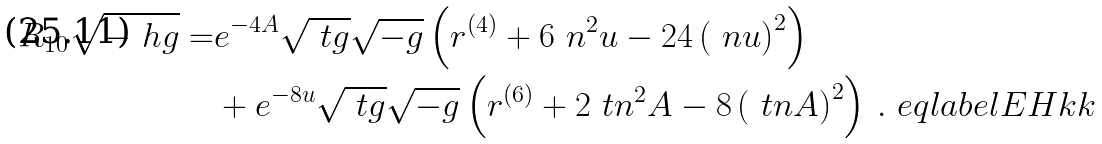<formula> <loc_0><loc_0><loc_500><loc_500>R _ { 1 0 } \sqrt { - \ h g } = & e ^ { - 4 A } \sqrt { \ t g } \sqrt { - g } \left ( r ^ { ( 4 ) } + 6 \ n ^ { 2 } u - 2 4 \left ( \ n u \right ) ^ { 2 } \right ) \\ & + e ^ { - 8 u } \sqrt { \ t g } \sqrt { - g } \left ( r ^ { ( 6 ) } + 2 \ t n ^ { 2 } A - 8 \left ( \ t n A \right ) ^ { 2 } \right ) \, . \ e q l a b e l { E H k k }</formula> 